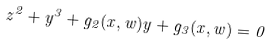Convert formula to latex. <formula><loc_0><loc_0><loc_500><loc_500>z ^ { 2 } + y ^ { 3 } + g _ { 2 } ( x , w ) y + g _ { 3 } ( x , w ) = 0</formula> 